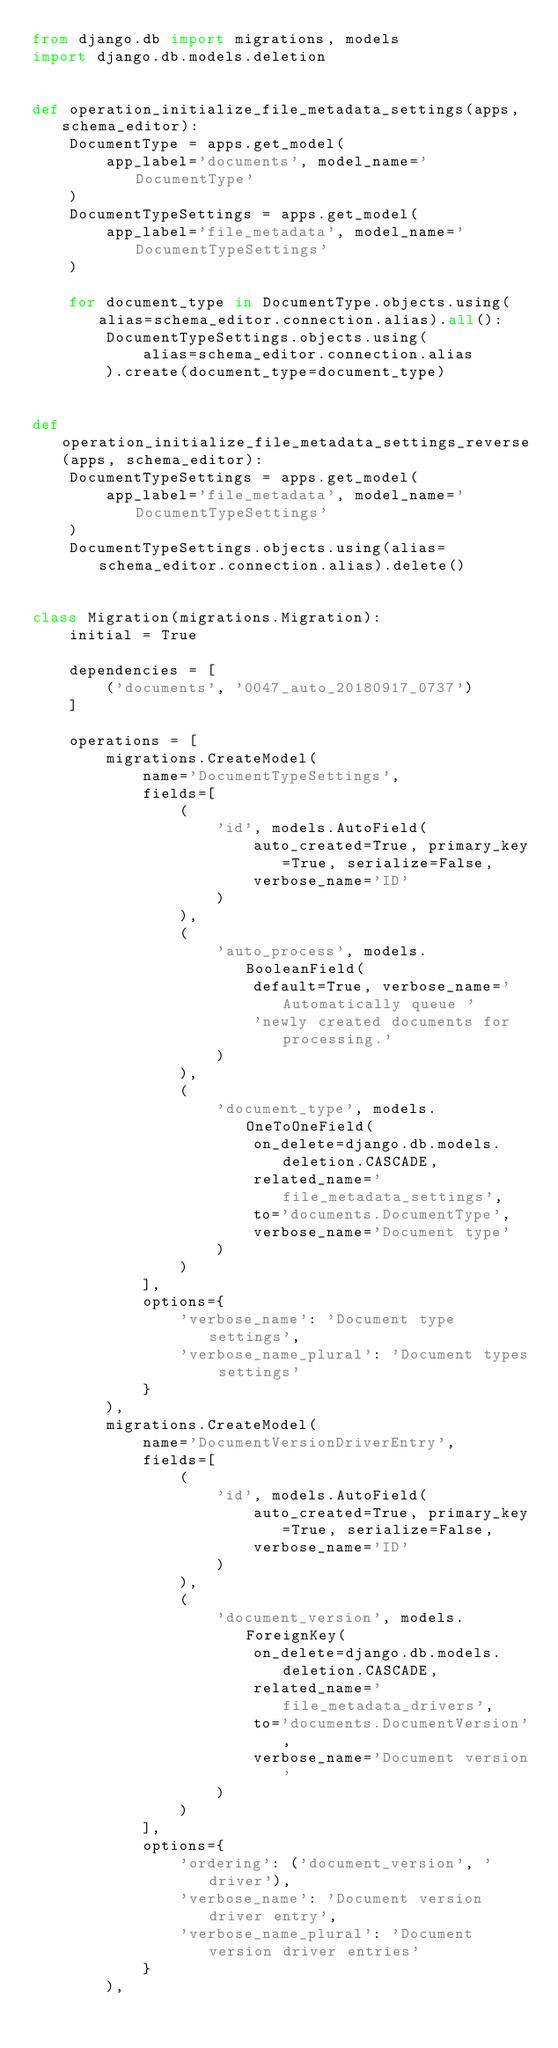Convert code to text. <code><loc_0><loc_0><loc_500><loc_500><_Python_>from django.db import migrations, models
import django.db.models.deletion


def operation_initialize_file_metadata_settings(apps, schema_editor):
    DocumentType = apps.get_model(
        app_label='documents', model_name='DocumentType'
    )
    DocumentTypeSettings = apps.get_model(
        app_label='file_metadata', model_name='DocumentTypeSettings'
    )

    for document_type in DocumentType.objects.using(alias=schema_editor.connection.alias).all():
        DocumentTypeSettings.objects.using(
            alias=schema_editor.connection.alias
        ).create(document_type=document_type)


def operation_initialize_file_metadata_settings_reverse(apps, schema_editor):
    DocumentTypeSettings = apps.get_model(
        app_label='file_metadata', model_name='DocumentTypeSettings'
    )
    DocumentTypeSettings.objects.using(alias=schema_editor.connection.alias).delete()


class Migration(migrations.Migration):
    initial = True

    dependencies = [
        ('documents', '0047_auto_20180917_0737')
    ]

    operations = [
        migrations.CreateModel(
            name='DocumentTypeSettings',
            fields=[
                (
                    'id', models.AutoField(
                        auto_created=True, primary_key=True, serialize=False,
                        verbose_name='ID'
                    )
                ),
                (
                    'auto_process', models.BooleanField(
                        default=True, verbose_name='Automatically queue '
                        'newly created documents for processing.'
                    )
                ),
                (
                    'document_type', models.OneToOneField(
                        on_delete=django.db.models.deletion.CASCADE,
                        related_name='file_metadata_settings',
                        to='documents.DocumentType',
                        verbose_name='Document type'
                    )
                )
            ],
            options={
                'verbose_name': 'Document type settings',
                'verbose_name_plural': 'Document types settings'
            }
        ),
        migrations.CreateModel(
            name='DocumentVersionDriverEntry',
            fields=[
                (
                    'id', models.AutoField(
                        auto_created=True, primary_key=True, serialize=False,
                        verbose_name='ID'
                    )
                ),
                (
                    'document_version', models.ForeignKey(
                        on_delete=django.db.models.deletion.CASCADE,
                        related_name='file_metadata_drivers',
                        to='documents.DocumentVersion',
                        verbose_name='Document version'
                    )
                )
            ],
            options={
                'ordering': ('document_version', 'driver'),
                'verbose_name': 'Document version driver entry',
                'verbose_name_plural': 'Document version driver entries'
            }
        ),</code> 